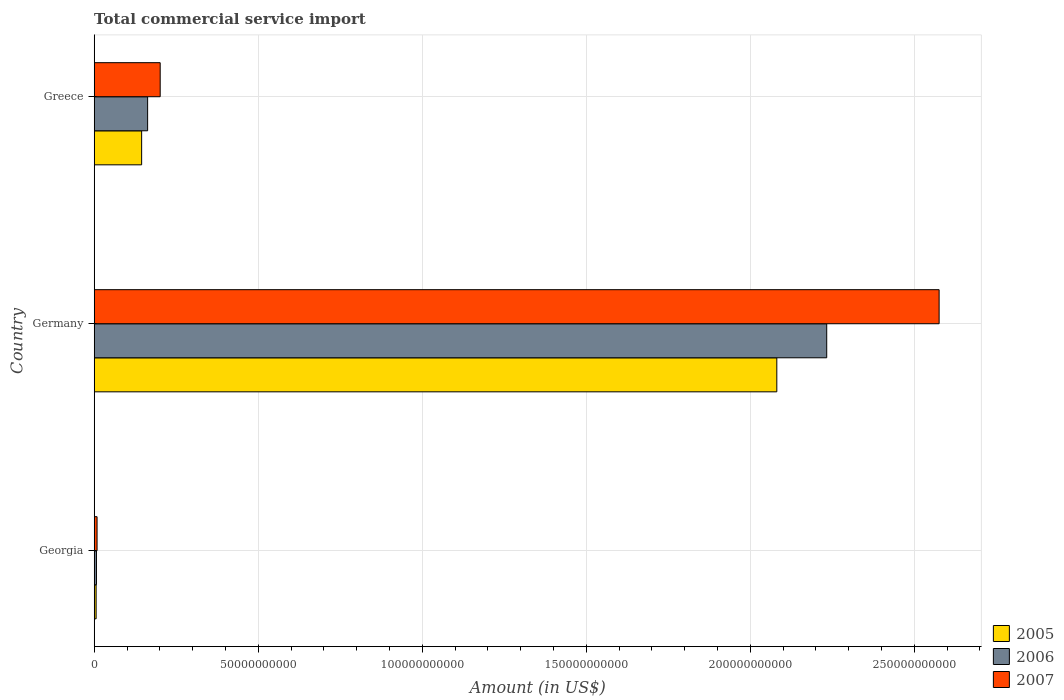How many different coloured bars are there?
Ensure brevity in your answer.  3. Are the number of bars per tick equal to the number of legend labels?
Your answer should be very brief. Yes. How many bars are there on the 3rd tick from the bottom?
Provide a succinct answer. 3. What is the label of the 3rd group of bars from the top?
Provide a short and direct response. Georgia. In how many cases, is the number of bars for a given country not equal to the number of legend labels?
Your answer should be very brief. 0. What is the total commercial service import in 2006 in Germany?
Provide a short and direct response. 2.23e+11. Across all countries, what is the maximum total commercial service import in 2006?
Your answer should be compact. 2.23e+11. Across all countries, what is the minimum total commercial service import in 2006?
Ensure brevity in your answer.  6.93e+08. In which country was the total commercial service import in 2005 maximum?
Your answer should be compact. Germany. In which country was the total commercial service import in 2005 minimum?
Your answer should be very brief. Georgia. What is the total total commercial service import in 2007 in the graph?
Ensure brevity in your answer.  2.79e+11. What is the difference between the total commercial service import in 2006 in Georgia and that in Greece?
Provide a succinct answer. -1.56e+1. What is the difference between the total commercial service import in 2007 in Greece and the total commercial service import in 2006 in Georgia?
Provide a short and direct response. 1.94e+1. What is the average total commercial service import in 2007 per country?
Ensure brevity in your answer.  9.29e+1. What is the difference between the total commercial service import in 2007 and total commercial service import in 2006 in Germany?
Make the answer very short. 3.43e+1. In how many countries, is the total commercial service import in 2006 greater than 150000000000 US$?
Offer a very short reply. 1. What is the ratio of the total commercial service import in 2006 in Georgia to that in Germany?
Provide a short and direct response. 0. Is the total commercial service import in 2007 in Georgia less than that in Greece?
Give a very brief answer. Yes. Is the difference between the total commercial service import in 2007 in Germany and Greece greater than the difference between the total commercial service import in 2006 in Germany and Greece?
Your answer should be compact. Yes. What is the difference between the highest and the second highest total commercial service import in 2006?
Ensure brevity in your answer.  2.07e+11. What is the difference between the highest and the lowest total commercial service import in 2005?
Offer a terse response. 2.08e+11. What does the 2nd bar from the top in Georgia represents?
Your response must be concise. 2006. Is it the case that in every country, the sum of the total commercial service import in 2005 and total commercial service import in 2006 is greater than the total commercial service import in 2007?
Your response must be concise. Yes. How many countries are there in the graph?
Give a very brief answer. 3. What is the difference between two consecutive major ticks on the X-axis?
Your answer should be compact. 5.00e+1. Does the graph contain any zero values?
Give a very brief answer. No. Where does the legend appear in the graph?
Ensure brevity in your answer.  Bottom right. How are the legend labels stacked?
Make the answer very short. Vertical. What is the title of the graph?
Ensure brevity in your answer.  Total commercial service import. Does "2002" appear as one of the legend labels in the graph?
Your response must be concise. No. What is the label or title of the X-axis?
Your answer should be very brief. Amount (in US$). What is the Amount (in US$) of 2005 in Georgia?
Your answer should be compact. 5.88e+08. What is the Amount (in US$) of 2006 in Georgia?
Provide a short and direct response. 6.93e+08. What is the Amount (in US$) of 2007 in Georgia?
Give a very brief answer. 8.74e+08. What is the Amount (in US$) of 2005 in Germany?
Make the answer very short. 2.08e+11. What is the Amount (in US$) in 2006 in Germany?
Make the answer very short. 2.23e+11. What is the Amount (in US$) in 2007 in Germany?
Your answer should be very brief. 2.58e+11. What is the Amount (in US$) of 2005 in Greece?
Ensure brevity in your answer.  1.45e+1. What is the Amount (in US$) of 2006 in Greece?
Provide a succinct answer. 1.63e+1. What is the Amount (in US$) of 2007 in Greece?
Provide a succinct answer. 2.01e+1. Across all countries, what is the maximum Amount (in US$) in 2005?
Your answer should be very brief. 2.08e+11. Across all countries, what is the maximum Amount (in US$) of 2006?
Provide a short and direct response. 2.23e+11. Across all countries, what is the maximum Amount (in US$) in 2007?
Make the answer very short. 2.58e+11. Across all countries, what is the minimum Amount (in US$) in 2005?
Your response must be concise. 5.88e+08. Across all countries, what is the minimum Amount (in US$) in 2006?
Your response must be concise. 6.93e+08. Across all countries, what is the minimum Amount (in US$) of 2007?
Provide a succinct answer. 8.74e+08. What is the total Amount (in US$) of 2005 in the graph?
Keep it short and to the point. 2.23e+11. What is the total Amount (in US$) in 2006 in the graph?
Provide a succinct answer. 2.40e+11. What is the total Amount (in US$) in 2007 in the graph?
Keep it short and to the point. 2.79e+11. What is the difference between the Amount (in US$) of 2005 in Georgia and that in Germany?
Make the answer very short. -2.08e+11. What is the difference between the Amount (in US$) of 2006 in Georgia and that in Germany?
Offer a very short reply. -2.23e+11. What is the difference between the Amount (in US$) in 2007 in Georgia and that in Germany?
Give a very brief answer. -2.57e+11. What is the difference between the Amount (in US$) of 2005 in Georgia and that in Greece?
Make the answer very short. -1.39e+1. What is the difference between the Amount (in US$) of 2006 in Georgia and that in Greece?
Provide a succinct answer. -1.56e+1. What is the difference between the Amount (in US$) of 2007 in Georgia and that in Greece?
Offer a very short reply. -1.92e+1. What is the difference between the Amount (in US$) in 2005 in Germany and that in Greece?
Offer a terse response. 1.94e+11. What is the difference between the Amount (in US$) of 2006 in Germany and that in Greece?
Your response must be concise. 2.07e+11. What is the difference between the Amount (in US$) of 2007 in Germany and that in Greece?
Keep it short and to the point. 2.37e+11. What is the difference between the Amount (in US$) of 2005 in Georgia and the Amount (in US$) of 2006 in Germany?
Offer a terse response. -2.23e+11. What is the difference between the Amount (in US$) in 2005 in Georgia and the Amount (in US$) in 2007 in Germany?
Offer a terse response. -2.57e+11. What is the difference between the Amount (in US$) in 2006 in Georgia and the Amount (in US$) in 2007 in Germany?
Keep it short and to the point. -2.57e+11. What is the difference between the Amount (in US$) of 2005 in Georgia and the Amount (in US$) of 2006 in Greece?
Give a very brief answer. -1.57e+1. What is the difference between the Amount (in US$) of 2005 in Georgia and the Amount (in US$) of 2007 in Greece?
Keep it short and to the point. -1.95e+1. What is the difference between the Amount (in US$) of 2006 in Georgia and the Amount (in US$) of 2007 in Greece?
Keep it short and to the point. -1.94e+1. What is the difference between the Amount (in US$) in 2005 in Germany and the Amount (in US$) in 2006 in Greece?
Your answer should be compact. 1.92e+11. What is the difference between the Amount (in US$) in 2005 in Germany and the Amount (in US$) in 2007 in Greece?
Your answer should be very brief. 1.88e+11. What is the difference between the Amount (in US$) in 2006 in Germany and the Amount (in US$) in 2007 in Greece?
Give a very brief answer. 2.03e+11. What is the average Amount (in US$) in 2005 per country?
Offer a very short reply. 7.44e+1. What is the average Amount (in US$) of 2006 per country?
Your answer should be very brief. 8.01e+1. What is the average Amount (in US$) in 2007 per country?
Give a very brief answer. 9.29e+1. What is the difference between the Amount (in US$) in 2005 and Amount (in US$) in 2006 in Georgia?
Your response must be concise. -1.05e+08. What is the difference between the Amount (in US$) of 2005 and Amount (in US$) of 2007 in Georgia?
Your answer should be very brief. -2.86e+08. What is the difference between the Amount (in US$) of 2006 and Amount (in US$) of 2007 in Georgia?
Provide a short and direct response. -1.81e+08. What is the difference between the Amount (in US$) in 2005 and Amount (in US$) in 2006 in Germany?
Give a very brief answer. -1.52e+1. What is the difference between the Amount (in US$) of 2005 and Amount (in US$) of 2007 in Germany?
Your answer should be compact. -4.95e+1. What is the difference between the Amount (in US$) in 2006 and Amount (in US$) in 2007 in Germany?
Your response must be concise. -3.43e+1. What is the difference between the Amount (in US$) of 2005 and Amount (in US$) of 2006 in Greece?
Provide a short and direct response. -1.83e+09. What is the difference between the Amount (in US$) in 2005 and Amount (in US$) in 2007 in Greece?
Offer a very short reply. -5.65e+09. What is the difference between the Amount (in US$) of 2006 and Amount (in US$) of 2007 in Greece?
Offer a terse response. -3.83e+09. What is the ratio of the Amount (in US$) of 2005 in Georgia to that in Germany?
Provide a short and direct response. 0. What is the ratio of the Amount (in US$) of 2006 in Georgia to that in Germany?
Provide a succinct answer. 0. What is the ratio of the Amount (in US$) of 2007 in Georgia to that in Germany?
Offer a very short reply. 0. What is the ratio of the Amount (in US$) of 2005 in Georgia to that in Greece?
Your answer should be compact. 0.04. What is the ratio of the Amount (in US$) of 2006 in Georgia to that in Greece?
Give a very brief answer. 0.04. What is the ratio of the Amount (in US$) in 2007 in Georgia to that in Greece?
Provide a succinct answer. 0.04. What is the ratio of the Amount (in US$) in 2005 in Germany to that in Greece?
Ensure brevity in your answer.  14.39. What is the ratio of the Amount (in US$) of 2006 in Germany to that in Greece?
Provide a short and direct response. 13.71. What is the ratio of the Amount (in US$) of 2007 in Germany to that in Greece?
Your answer should be very brief. 12.8. What is the difference between the highest and the second highest Amount (in US$) of 2005?
Keep it short and to the point. 1.94e+11. What is the difference between the highest and the second highest Amount (in US$) in 2006?
Offer a terse response. 2.07e+11. What is the difference between the highest and the second highest Amount (in US$) of 2007?
Provide a succinct answer. 2.37e+11. What is the difference between the highest and the lowest Amount (in US$) of 2005?
Make the answer very short. 2.08e+11. What is the difference between the highest and the lowest Amount (in US$) in 2006?
Give a very brief answer. 2.23e+11. What is the difference between the highest and the lowest Amount (in US$) of 2007?
Offer a terse response. 2.57e+11. 